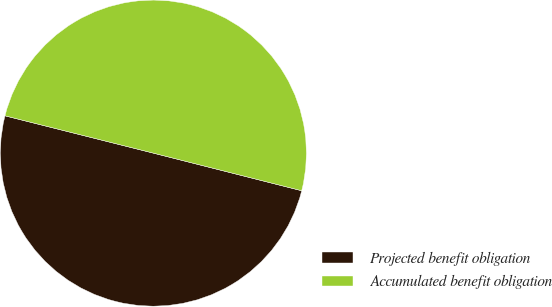<chart> <loc_0><loc_0><loc_500><loc_500><pie_chart><fcel>Projected benefit obligation<fcel>Accumulated benefit obligation<nl><fcel>49.97%<fcel>50.03%<nl></chart> 